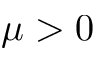<formula> <loc_0><loc_0><loc_500><loc_500>\mu > 0</formula> 